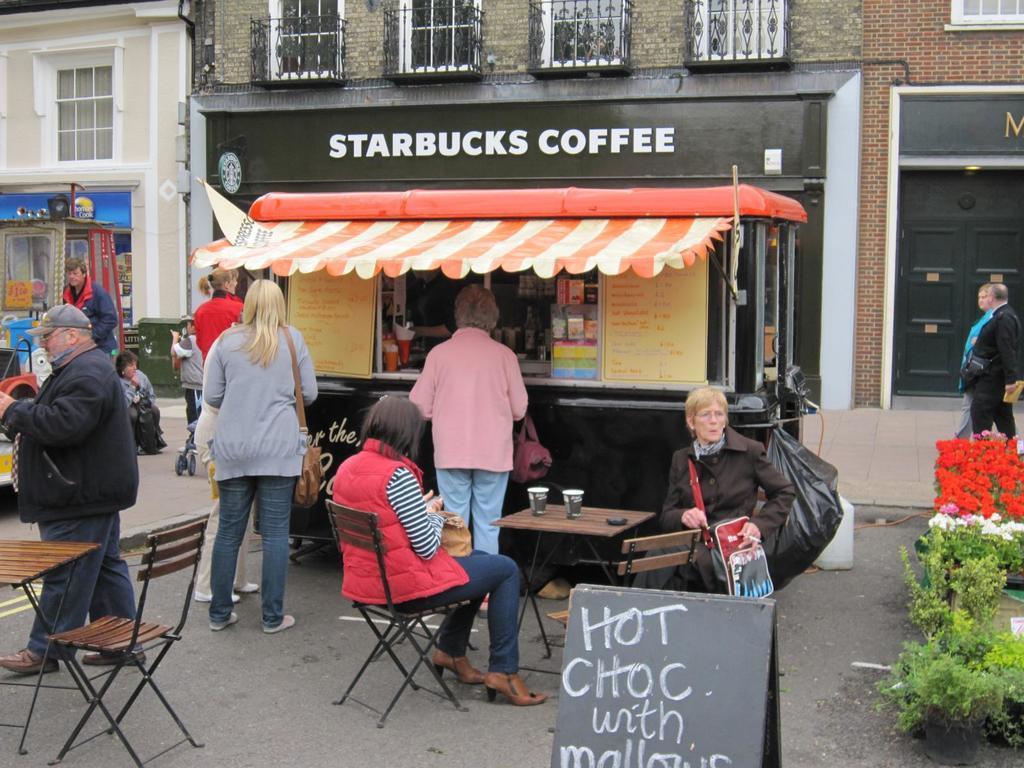In one or two sentences, can you explain what this image depicts? In this image there are 2 persons sitting in chair , and in table there are 2 glasses , at the back ground there are group of people standing in a street , a coffee shop, tent, there is building, plants, name board or hoarding. 